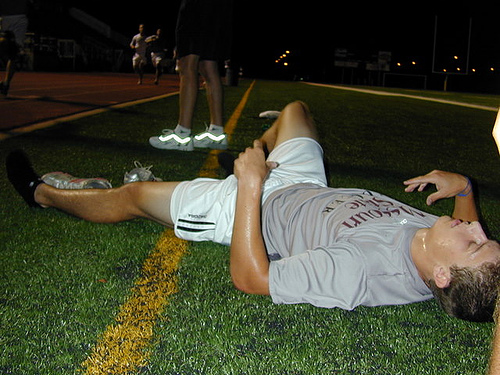<image>
Can you confirm if the shoe is on the man? No. The shoe is not positioned on the man. They may be near each other, but the shoe is not supported by or resting on top of the man. 